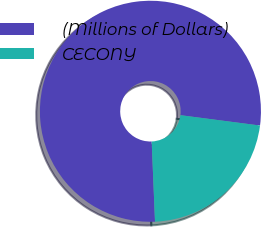Convert chart to OTSL. <chart><loc_0><loc_0><loc_500><loc_500><pie_chart><fcel>(Millions of Dollars)<fcel>CECONY<nl><fcel>77.72%<fcel>22.28%<nl></chart> 